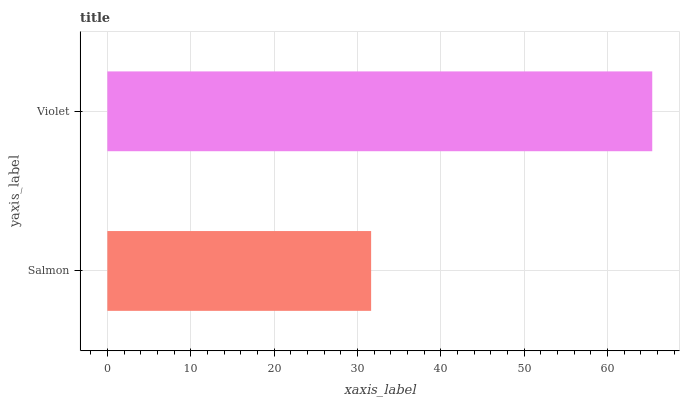Is Salmon the minimum?
Answer yes or no. Yes. Is Violet the maximum?
Answer yes or no. Yes. Is Violet the minimum?
Answer yes or no. No. Is Violet greater than Salmon?
Answer yes or no. Yes. Is Salmon less than Violet?
Answer yes or no. Yes. Is Salmon greater than Violet?
Answer yes or no. No. Is Violet less than Salmon?
Answer yes or no. No. Is Violet the high median?
Answer yes or no. Yes. Is Salmon the low median?
Answer yes or no. Yes. Is Salmon the high median?
Answer yes or no. No. Is Violet the low median?
Answer yes or no. No. 